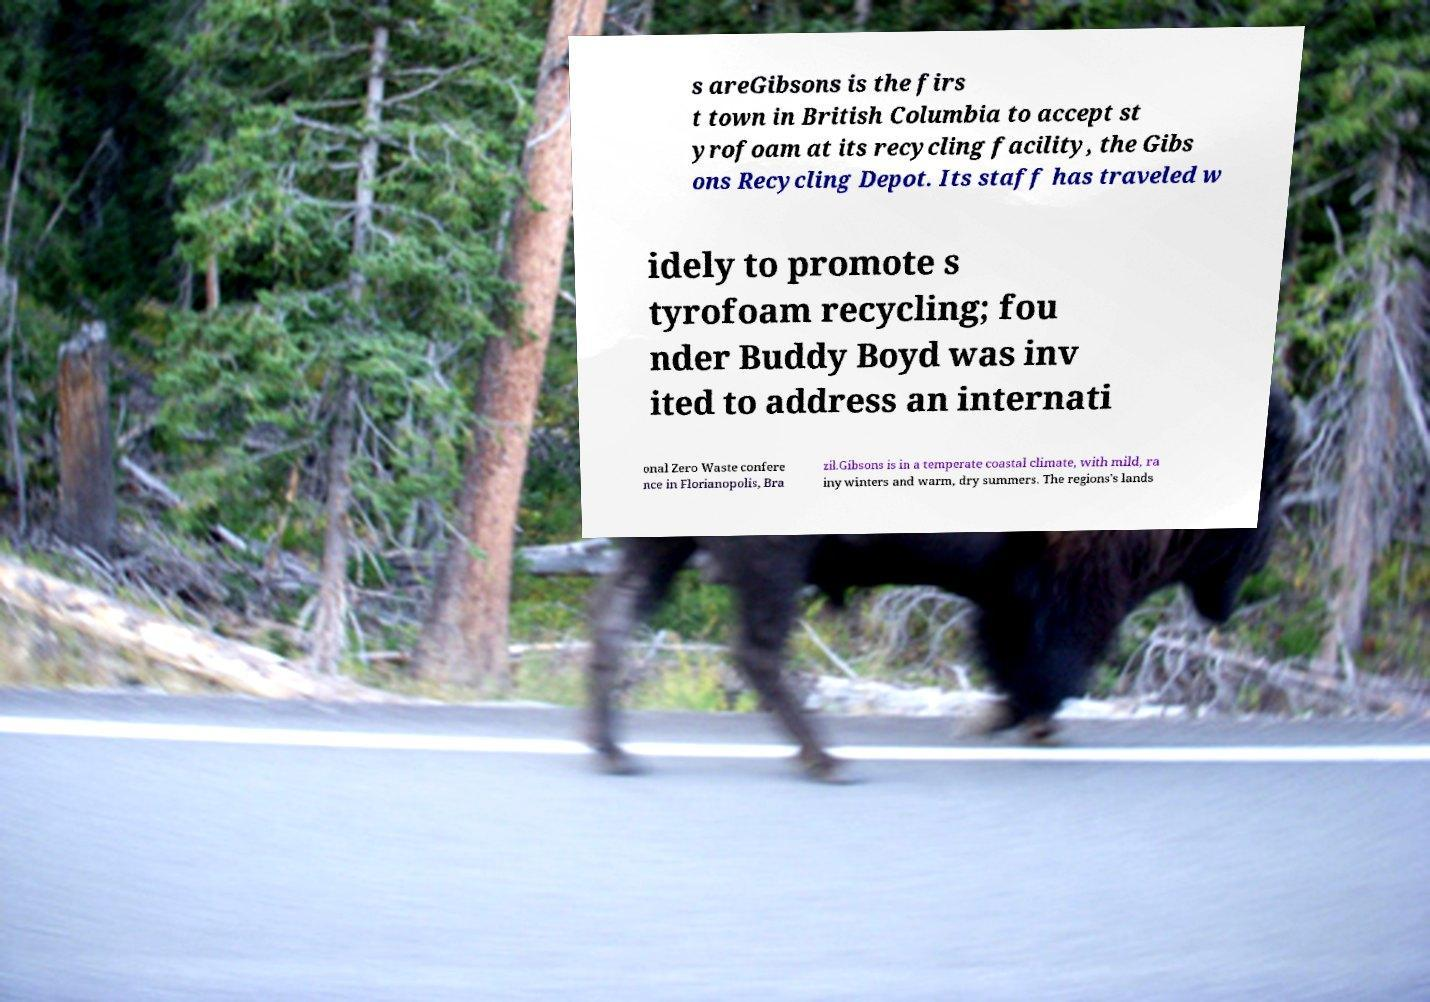Could you assist in decoding the text presented in this image and type it out clearly? s areGibsons is the firs t town in British Columbia to accept st yrofoam at its recycling facility, the Gibs ons Recycling Depot. Its staff has traveled w idely to promote s tyrofoam recycling; fou nder Buddy Boyd was inv ited to address an internati onal Zero Waste confere nce in Florianopolis, Bra zil.Gibsons is in a temperate coastal climate, with mild, ra iny winters and warm, dry summers. The regions's lands 